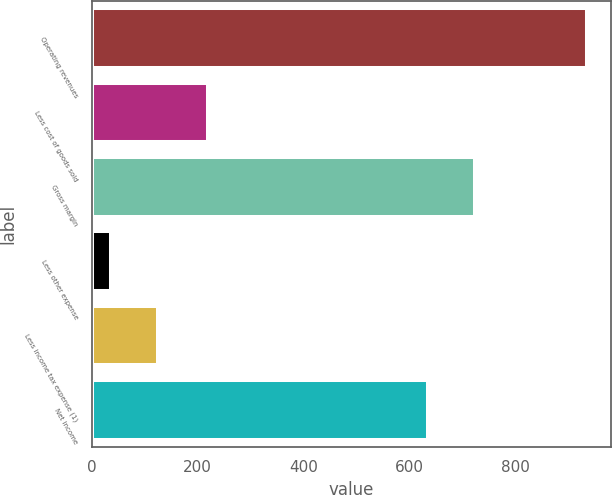Convert chart to OTSL. <chart><loc_0><loc_0><loc_500><loc_500><bar_chart><fcel>Operating revenues<fcel>Less cost of goods sold<fcel>Gross margin<fcel>Less other expense<fcel>Less income tax expense (1)<fcel>Net income<nl><fcel>934<fcel>220<fcel>723.8<fcel>36<fcel>125.8<fcel>634<nl></chart> 